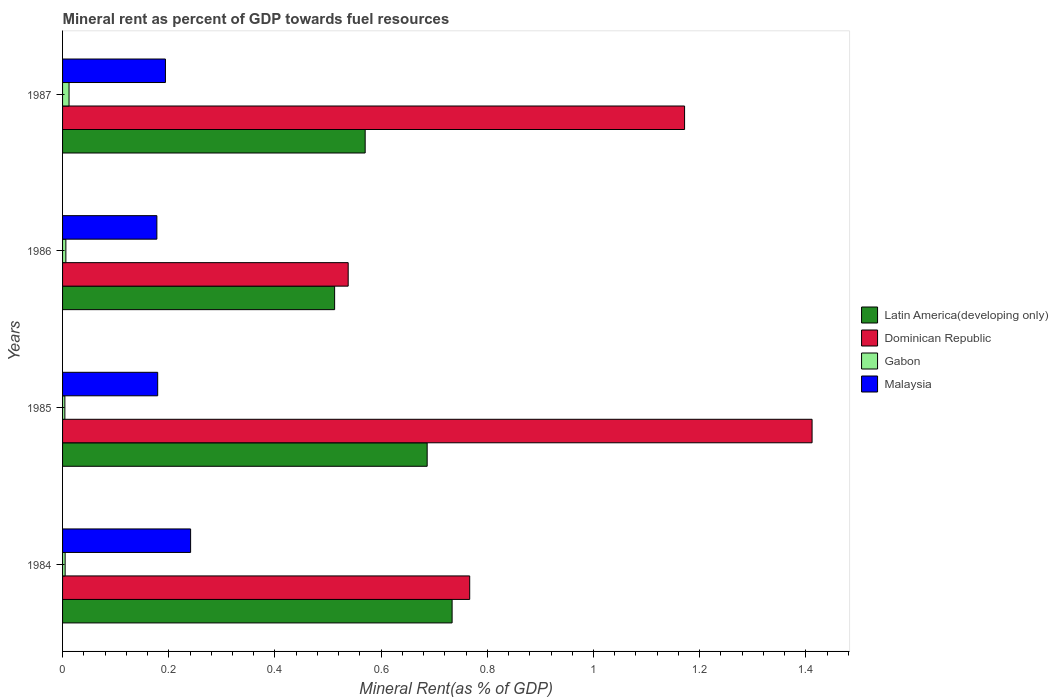How many groups of bars are there?
Give a very brief answer. 4. How many bars are there on the 1st tick from the top?
Ensure brevity in your answer.  4. How many bars are there on the 1st tick from the bottom?
Offer a terse response. 4. What is the label of the 2nd group of bars from the top?
Offer a terse response. 1986. What is the mineral rent in Latin America(developing only) in 1984?
Provide a short and direct response. 0.73. Across all years, what is the maximum mineral rent in Latin America(developing only)?
Ensure brevity in your answer.  0.73. Across all years, what is the minimum mineral rent in Dominican Republic?
Make the answer very short. 0.54. In which year was the mineral rent in Dominican Republic maximum?
Your answer should be compact. 1985. What is the total mineral rent in Gabon in the graph?
Ensure brevity in your answer.  0.03. What is the difference between the mineral rent in Dominican Republic in 1985 and that in 1987?
Give a very brief answer. 0.24. What is the difference between the mineral rent in Malaysia in 1986 and the mineral rent in Dominican Republic in 1984?
Give a very brief answer. -0.59. What is the average mineral rent in Latin America(developing only) per year?
Offer a very short reply. 0.63. In the year 1987, what is the difference between the mineral rent in Latin America(developing only) and mineral rent in Gabon?
Your answer should be very brief. 0.56. What is the ratio of the mineral rent in Dominican Republic in 1985 to that in 1986?
Give a very brief answer. 2.62. Is the mineral rent in Malaysia in 1985 less than that in 1987?
Keep it short and to the point. Yes. What is the difference between the highest and the second highest mineral rent in Dominican Republic?
Your answer should be compact. 0.24. What is the difference between the highest and the lowest mineral rent in Dominican Republic?
Offer a very short reply. 0.87. In how many years, is the mineral rent in Gabon greater than the average mineral rent in Gabon taken over all years?
Provide a short and direct response. 1. Is the sum of the mineral rent in Malaysia in 1984 and 1985 greater than the maximum mineral rent in Latin America(developing only) across all years?
Keep it short and to the point. No. Is it the case that in every year, the sum of the mineral rent in Latin America(developing only) and mineral rent in Gabon is greater than the sum of mineral rent in Dominican Republic and mineral rent in Malaysia?
Your response must be concise. Yes. What does the 2nd bar from the top in 1984 represents?
Your answer should be very brief. Gabon. What does the 1st bar from the bottom in 1984 represents?
Provide a short and direct response. Latin America(developing only). Is it the case that in every year, the sum of the mineral rent in Dominican Republic and mineral rent in Gabon is greater than the mineral rent in Malaysia?
Provide a succinct answer. Yes. How many bars are there?
Give a very brief answer. 16. Are all the bars in the graph horizontal?
Offer a very short reply. Yes. How many years are there in the graph?
Offer a terse response. 4. What is the difference between two consecutive major ticks on the X-axis?
Offer a very short reply. 0.2. Are the values on the major ticks of X-axis written in scientific E-notation?
Provide a short and direct response. No. Does the graph contain any zero values?
Keep it short and to the point. No. Where does the legend appear in the graph?
Keep it short and to the point. Center right. What is the title of the graph?
Give a very brief answer. Mineral rent as percent of GDP towards fuel resources. Does "St. Lucia" appear as one of the legend labels in the graph?
Provide a short and direct response. No. What is the label or title of the X-axis?
Give a very brief answer. Mineral Rent(as % of GDP). What is the label or title of the Y-axis?
Your answer should be compact. Years. What is the Mineral Rent(as % of GDP) in Latin America(developing only) in 1984?
Your response must be concise. 0.73. What is the Mineral Rent(as % of GDP) in Dominican Republic in 1984?
Give a very brief answer. 0.77. What is the Mineral Rent(as % of GDP) of Gabon in 1984?
Your response must be concise. 0. What is the Mineral Rent(as % of GDP) in Malaysia in 1984?
Your answer should be compact. 0.24. What is the Mineral Rent(as % of GDP) of Latin America(developing only) in 1985?
Keep it short and to the point. 0.69. What is the Mineral Rent(as % of GDP) in Dominican Republic in 1985?
Your answer should be compact. 1.41. What is the Mineral Rent(as % of GDP) of Gabon in 1985?
Your answer should be very brief. 0. What is the Mineral Rent(as % of GDP) of Malaysia in 1985?
Keep it short and to the point. 0.18. What is the Mineral Rent(as % of GDP) in Latin America(developing only) in 1986?
Ensure brevity in your answer.  0.51. What is the Mineral Rent(as % of GDP) of Dominican Republic in 1986?
Keep it short and to the point. 0.54. What is the Mineral Rent(as % of GDP) in Gabon in 1986?
Make the answer very short. 0.01. What is the Mineral Rent(as % of GDP) in Malaysia in 1986?
Offer a terse response. 0.18. What is the Mineral Rent(as % of GDP) in Latin America(developing only) in 1987?
Ensure brevity in your answer.  0.57. What is the Mineral Rent(as % of GDP) of Dominican Republic in 1987?
Your response must be concise. 1.17. What is the Mineral Rent(as % of GDP) in Gabon in 1987?
Offer a terse response. 0.01. What is the Mineral Rent(as % of GDP) in Malaysia in 1987?
Provide a short and direct response. 0.19. Across all years, what is the maximum Mineral Rent(as % of GDP) of Latin America(developing only)?
Provide a succinct answer. 0.73. Across all years, what is the maximum Mineral Rent(as % of GDP) in Dominican Republic?
Your answer should be compact. 1.41. Across all years, what is the maximum Mineral Rent(as % of GDP) in Gabon?
Provide a short and direct response. 0.01. Across all years, what is the maximum Mineral Rent(as % of GDP) of Malaysia?
Provide a succinct answer. 0.24. Across all years, what is the minimum Mineral Rent(as % of GDP) of Latin America(developing only)?
Your response must be concise. 0.51. Across all years, what is the minimum Mineral Rent(as % of GDP) in Dominican Republic?
Your response must be concise. 0.54. Across all years, what is the minimum Mineral Rent(as % of GDP) in Gabon?
Give a very brief answer. 0. Across all years, what is the minimum Mineral Rent(as % of GDP) of Malaysia?
Provide a short and direct response. 0.18. What is the total Mineral Rent(as % of GDP) in Latin America(developing only) in the graph?
Your response must be concise. 2.5. What is the total Mineral Rent(as % of GDP) in Dominican Republic in the graph?
Your answer should be very brief. 3.89. What is the total Mineral Rent(as % of GDP) in Gabon in the graph?
Offer a terse response. 0.03. What is the total Mineral Rent(as % of GDP) of Malaysia in the graph?
Give a very brief answer. 0.79. What is the difference between the Mineral Rent(as % of GDP) in Latin America(developing only) in 1984 and that in 1985?
Your answer should be very brief. 0.05. What is the difference between the Mineral Rent(as % of GDP) in Dominican Republic in 1984 and that in 1985?
Provide a succinct answer. -0.64. What is the difference between the Mineral Rent(as % of GDP) of Gabon in 1984 and that in 1985?
Give a very brief answer. 0. What is the difference between the Mineral Rent(as % of GDP) in Malaysia in 1984 and that in 1985?
Offer a terse response. 0.06. What is the difference between the Mineral Rent(as % of GDP) in Latin America(developing only) in 1984 and that in 1986?
Give a very brief answer. 0.22. What is the difference between the Mineral Rent(as % of GDP) of Dominican Republic in 1984 and that in 1986?
Make the answer very short. 0.23. What is the difference between the Mineral Rent(as % of GDP) of Gabon in 1984 and that in 1986?
Your answer should be very brief. -0. What is the difference between the Mineral Rent(as % of GDP) in Malaysia in 1984 and that in 1986?
Your answer should be compact. 0.06. What is the difference between the Mineral Rent(as % of GDP) in Latin America(developing only) in 1984 and that in 1987?
Give a very brief answer. 0.16. What is the difference between the Mineral Rent(as % of GDP) of Dominican Republic in 1984 and that in 1987?
Offer a terse response. -0.4. What is the difference between the Mineral Rent(as % of GDP) in Gabon in 1984 and that in 1987?
Your response must be concise. -0.01. What is the difference between the Mineral Rent(as % of GDP) of Malaysia in 1984 and that in 1987?
Your answer should be very brief. 0.05. What is the difference between the Mineral Rent(as % of GDP) of Latin America(developing only) in 1985 and that in 1986?
Your response must be concise. 0.17. What is the difference between the Mineral Rent(as % of GDP) of Dominican Republic in 1985 and that in 1986?
Provide a short and direct response. 0.87. What is the difference between the Mineral Rent(as % of GDP) in Gabon in 1985 and that in 1986?
Offer a very short reply. -0. What is the difference between the Mineral Rent(as % of GDP) of Malaysia in 1985 and that in 1986?
Provide a short and direct response. 0. What is the difference between the Mineral Rent(as % of GDP) of Latin America(developing only) in 1985 and that in 1987?
Offer a very short reply. 0.12. What is the difference between the Mineral Rent(as % of GDP) of Dominican Republic in 1985 and that in 1987?
Your answer should be very brief. 0.24. What is the difference between the Mineral Rent(as % of GDP) of Gabon in 1985 and that in 1987?
Your answer should be very brief. -0.01. What is the difference between the Mineral Rent(as % of GDP) in Malaysia in 1985 and that in 1987?
Your response must be concise. -0.01. What is the difference between the Mineral Rent(as % of GDP) in Latin America(developing only) in 1986 and that in 1987?
Keep it short and to the point. -0.06. What is the difference between the Mineral Rent(as % of GDP) in Dominican Republic in 1986 and that in 1987?
Provide a short and direct response. -0.63. What is the difference between the Mineral Rent(as % of GDP) in Gabon in 1986 and that in 1987?
Provide a short and direct response. -0.01. What is the difference between the Mineral Rent(as % of GDP) of Malaysia in 1986 and that in 1987?
Provide a succinct answer. -0.02. What is the difference between the Mineral Rent(as % of GDP) in Latin America(developing only) in 1984 and the Mineral Rent(as % of GDP) in Dominican Republic in 1985?
Keep it short and to the point. -0.68. What is the difference between the Mineral Rent(as % of GDP) in Latin America(developing only) in 1984 and the Mineral Rent(as % of GDP) in Gabon in 1985?
Offer a terse response. 0.73. What is the difference between the Mineral Rent(as % of GDP) of Latin America(developing only) in 1984 and the Mineral Rent(as % of GDP) of Malaysia in 1985?
Your response must be concise. 0.55. What is the difference between the Mineral Rent(as % of GDP) in Dominican Republic in 1984 and the Mineral Rent(as % of GDP) in Gabon in 1985?
Provide a succinct answer. 0.76. What is the difference between the Mineral Rent(as % of GDP) of Dominican Republic in 1984 and the Mineral Rent(as % of GDP) of Malaysia in 1985?
Provide a short and direct response. 0.59. What is the difference between the Mineral Rent(as % of GDP) in Gabon in 1984 and the Mineral Rent(as % of GDP) in Malaysia in 1985?
Offer a terse response. -0.17. What is the difference between the Mineral Rent(as % of GDP) in Latin America(developing only) in 1984 and the Mineral Rent(as % of GDP) in Dominican Republic in 1986?
Offer a terse response. 0.2. What is the difference between the Mineral Rent(as % of GDP) of Latin America(developing only) in 1984 and the Mineral Rent(as % of GDP) of Gabon in 1986?
Your answer should be very brief. 0.73. What is the difference between the Mineral Rent(as % of GDP) in Latin America(developing only) in 1984 and the Mineral Rent(as % of GDP) in Malaysia in 1986?
Your answer should be very brief. 0.56. What is the difference between the Mineral Rent(as % of GDP) of Dominican Republic in 1984 and the Mineral Rent(as % of GDP) of Gabon in 1986?
Make the answer very short. 0.76. What is the difference between the Mineral Rent(as % of GDP) of Dominican Republic in 1984 and the Mineral Rent(as % of GDP) of Malaysia in 1986?
Provide a succinct answer. 0.59. What is the difference between the Mineral Rent(as % of GDP) of Gabon in 1984 and the Mineral Rent(as % of GDP) of Malaysia in 1986?
Your response must be concise. -0.17. What is the difference between the Mineral Rent(as % of GDP) of Latin America(developing only) in 1984 and the Mineral Rent(as % of GDP) of Dominican Republic in 1987?
Your response must be concise. -0.44. What is the difference between the Mineral Rent(as % of GDP) in Latin America(developing only) in 1984 and the Mineral Rent(as % of GDP) in Gabon in 1987?
Ensure brevity in your answer.  0.72. What is the difference between the Mineral Rent(as % of GDP) of Latin America(developing only) in 1984 and the Mineral Rent(as % of GDP) of Malaysia in 1987?
Offer a terse response. 0.54. What is the difference between the Mineral Rent(as % of GDP) of Dominican Republic in 1984 and the Mineral Rent(as % of GDP) of Gabon in 1987?
Your response must be concise. 0.75. What is the difference between the Mineral Rent(as % of GDP) in Dominican Republic in 1984 and the Mineral Rent(as % of GDP) in Malaysia in 1987?
Give a very brief answer. 0.57. What is the difference between the Mineral Rent(as % of GDP) of Gabon in 1984 and the Mineral Rent(as % of GDP) of Malaysia in 1987?
Make the answer very short. -0.19. What is the difference between the Mineral Rent(as % of GDP) in Latin America(developing only) in 1985 and the Mineral Rent(as % of GDP) in Dominican Republic in 1986?
Keep it short and to the point. 0.15. What is the difference between the Mineral Rent(as % of GDP) in Latin America(developing only) in 1985 and the Mineral Rent(as % of GDP) in Gabon in 1986?
Your response must be concise. 0.68. What is the difference between the Mineral Rent(as % of GDP) in Latin America(developing only) in 1985 and the Mineral Rent(as % of GDP) in Malaysia in 1986?
Provide a short and direct response. 0.51. What is the difference between the Mineral Rent(as % of GDP) of Dominican Republic in 1985 and the Mineral Rent(as % of GDP) of Gabon in 1986?
Give a very brief answer. 1.41. What is the difference between the Mineral Rent(as % of GDP) of Dominican Republic in 1985 and the Mineral Rent(as % of GDP) of Malaysia in 1986?
Give a very brief answer. 1.23. What is the difference between the Mineral Rent(as % of GDP) of Gabon in 1985 and the Mineral Rent(as % of GDP) of Malaysia in 1986?
Offer a terse response. -0.17. What is the difference between the Mineral Rent(as % of GDP) of Latin America(developing only) in 1985 and the Mineral Rent(as % of GDP) of Dominican Republic in 1987?
Make the answer very short. -0.48. What is the difference between the Mineral Rent(as % of GDP) of Latin America(developing only) in 1985 and the Mineral Rent(as % of GDP) of Gabon in 1987?
Your answer should be very brief. 0.67. What is the difference between the Mineral Rent(as % of GDP) in Latin America(developing only) in 1985 and the Mineral Rent(as % of GDP) in Malaysia in 1987?
Give a very brief answer. 0.49. What is the difference between the Mineral Rent(as % of GDP) in Dominican Republic in 1985 and the Mineral Rent(as % of GDP) in Gabon in 1987?
Provide a succinct answer. 1.4. What is the difference between the Mineral Rent(as % of GDP) in Dominican Republic in 1985 and the Mineral Rent(as % of GDP) in Malaysia in 1987?
Your response must be concise. 1.22. What is the difference between the Mineral Rent(as % of GDP) of Gabon in 1985 and the Mineral Rent(as % of GDP) of Malaysia in 1987?
Ensure brevity in your answer.  -0.19. What is the difference between the Mineral Rent(as % of GDP) in Latin America(developing only) in 1986 and the Mineral Rent(as % of GDP) in Dominican Republic in 1987?
Ensure brevity in your answer.  -0.66. What is the difference between the Mineral Rent(as % of GDP) in Latin America(developing only) in 1986 and the Mineral Rent(as % of GDP) in Gabon in 1987?
Provide a succinct answer. 0.5. What is the difference between the Mineral Rent(as % of GDP) of Latin America(developing only) in 1986 and the Mineral Rent(as % of GDP) of Malaysia in 1987?
Give a very brief answer. 0.32. What is the difference between the Mineral Rent(as % of GDP) in Dominican Republic in 1986 and the Mineral Rent(as % of GDP) in Gabon in 1987?
Ensure brevity in your answer.  0.53. What is the difference between the Mineral Rent(as % of GDP) in Dominican Republic in 1986 and the Mineral Rent(as % of GDP) in Malaysia in 1987?
Your answer should be compact. 0.34. What is the difference between the Mineral Rent(as % of GDP) of Gabon in 1986 and the Mineral Rent(as % of GDP) of Malaysia in 1987?
Your response must be concise. -0.19. What is the average Mineral Rent(as % of GDP) in Latin America(developing only) per year?
Offer a very short reply. 0.63. What is the average Mineral Rent(as % of GDP) of Dominican Republic per year?
Offer a very short reply. 0.97. What is the average Mineral Rent(as % of GDP) of Gabon per year?
Offer a terse response. 0.01. What is the average Mineral Rent(as % of GDP) in Malaysia per year?
Your answer should be very brief. 0.2. In the year 1984, what is the difference between the Mineral Rent(as % of GDP) in Latin America(developing only) and Mineral Rent(as % of GDP) in Dominican Republic?
Offer a terse response. -0.03. In the year 1984, what is the difference between the Mineral Rent(as % of GDP) of Latin America(developing only) and Mineral Rent(as % of GDP) of Gabon?
Your answer should be very brief. 0.73. In the year 1984, what is the difference between the Mineral Rent(as % of GDP) of Latin America(developing only) and Mineral Rent(as % of GDP) of Malaysia?
Offer a very short reply. 0.49. In the year 1984, what is the difference between the Mineral Rent(as % of GDP) of Dominican Republic and Mineral Rent(as % of GDP) of Gabon?
Your answer should be very brief. 0.76. In the year 1984, what is the difference between the Mineral Rent(as % of GDP) in Dominican Republic and Mineral Rent(as % of GDP) in Malaysia?
Your answer should be very brief. 0.53. In the year 1984, what is the difference between the Mineral Rent(as % of GDP) of Gabon and Mineral Rent(as % of GDP) of Malaysia?
Give a very brief answer. -0.24. In the year 1985, what is the difference between the Mineral Rent(as % of GDP) of Latin America(developing only) and Mineral Rent(as % of GDP) of Dominican Republic?
Offer a very short reply. -0.72. In the year 1985, what is the difference between the Mineral Rent(as % of GDP) in Latin America(developing only) and Mineral Rent(as % of GDP) in Gabon?
Your answer should be very brief. 0.68. In the year 1985, what is the difference between the Mineral Rent(as % of GDP) in Latin America(developing only) and Mineral Rent(as % of GDP) in Malaysia?
Make the answer very short. 0.51. In the year 1985, what is the difference between the Mineral Rent(as % of GDP) of Dominican Republic and Mineral Rent(as % of GDP) of Gabon?
Your response must be concise. 1.41. In the year 1985, what is the difference between the Mineral Rent(as % of GDP) in Dominican Republic and Mineral Rent(as % of GDP) in Malaysia?
Offer a terse response. 1.23. In the year 1985, what is the difference between the Mineral Rent(as % of GDP) in Gabon and Mineral Rent(as % of GDP) in Malaysia?
Provide a short and direct response. -0.17. In the year 1986, what is the difference between the Mineral Rent(as % of GDP) in Latin America(developing only) and Mineral Rent(as % of GDP) in Dominican Republic?
Ensure brevity in your answer.  -0.03. In the year 1986, what is the difference between the Mineral Rent(as % of GDP) in Latin America(developing only) and Mineral Rent(as % of GDP) in Gabon?
Make the answer very short. 0.51. In the year 1986, what is the difference between the Mineral Rent(as % of GDP) of Latin America(developing only) and Mineral Rent(as % of GDP) of Malaysia?
Offer a terse response. 0.33. In the year 1986, what is the difference between the Mineral Rent(as % of GDP) of Dominican Republic and Mineral Rent(as % of GDP) of Gabon?
Your answer should be compact. 0.53. In the year 1986, what is the difference between the Mineral Rent(as % of GDP) in Dominican Republic and Mineral Rent(as % of GDP) in Malaysia?
Keep it short and to the point. 0.36. In the year 1986, what is the difference between the Mineral Rent(as % of GDP) of Gabon and Mineral Rent(as % of GDP) of Malaysia?
Offer a terse response. -0.17. In the year 1987, what is the difference between the Mineral Rent(as % of GDP) of Latin America(developing only) and Mineral Rent(as % of GDP) of Dominican Republic?
Provide a succinct answer. -0.6. In the year 1987, what is the difference between the Mineral Rent(as % of GDP) of Latin America(developing only) and Mineral Rent(as % of GDP) of Gabon?
Offer a terse response. 0.56. In the year 1987, what is the difference between the Mineral Rent(as % of GDP) in Latin America(developing only) and Mineral Rent(as % of GDP) in Malaysia?
Offer a very short reply. 0.38. In the year 1987, what is the difference between the Mineral Rent(as % of GDP) in Dominican Republic and Mineral Rent(as % of GDP) in Gabon?
Offer a very short reply. 1.16. In the year 1987, what is the difference between the Mineral Rent(as % of GDP) of Dominican Republic and Mineral Rent(as % of GDP) of Malaysia?
Your response must be concise. 0.98. In the year 1987, what is the difference between the Mineral Rent(as % of GDP) in Gabon and Mineral Rent(as % of GDP) in Malaysia?
Offer a very short reply. -0.18. What is the ratio of the Mineral Rent(as % of GDP) in Latin America(developing only) in 1984 to that in 1985?
Your answer should be compact. 1.07. What is the ratio of the Mineral Rent(as % of GDP) in Dominican Republic in 1984 to that in 1985?
Keep it short and to the point. 0.54. What is the ratio of the Mineral Rent(as % of GDP) of Gabon in 1984 to that in 1985?
Your answer should be very brief. 1.11. What is the ratio of the Mineral Rent(as % of GDP) of Malaysia in 1984 to that in 1985?
Keep it short and to the point. 1.35. What is the ratio of the Mineral Rent(as % of GDP) in Latin America(developing only) in 1984 to that in 1986?
Your answer should be very brief. 1.43. What is the ratio of the Mineral Rent(as % of GDP) in Dominican Republic in 1984 to that in 1986?
Your response must be concise. 1.43. What is the ratio of the Mineral Rent(as % of GDP) in Gabon in 1984 to that in 1986?
Keep it short and to the point. 0.78. What is the ratio of the Mineral Rent(as % of GDP) in Malaysia in 1984 to that in 1986?
Give a very brief answer. 1.36. What is the ratio of the Mineral Rent(as % of GDP) in Latin America(developing only) in 1984 to that in 1987?
Keep it short and to the point. 1.29. What is the ratio of the Mineral Rent(as % of GDP) in Dominican Republic in 1984 to that in 1987?
Offer a very short reply. 0.65. What is the ratio of the Mineral Rent(as % of GDP) of Gabon in 1984 to that in 1987?
Provide a succinct answer. 0.4. What is the ratio of the Mineral Rent(as % of GDP) of Malaysia in 1984 to that in 1987?
Your response must be concise. 1.24. What is the ratio of the Mineral Rent(as % of GDP) of Latin America(developing only) in 1985 to that in 1986?
Your response must be concise. 1.34. What is the ratio of the Mineral Rent(as % of GDP) in Dominican Republic in 1985 to that in 1986?
Your answer should be compact. 2.62. What is the ratio of the Mineral Rent(as % of GDP) in Gabon in 1985 to that in 1986?
Offer a terse response. 0.7. What is the ratio of the Mineral Rent(as % of GDP) in Malaysia in 1985 to that in 1986?
Offer a very short reply. 1.01. What is the ratio of the Mineral Rent(as % of GDP) of Latin America(developing only) in 1985 to that in 1987?
Ensure brevity in your answer.  1.2. What is the ratio of the Mineral Rent(as % of GDP) of Dominican Republic in 1985 to that in 1987?
Your response must be concise. 1.21. What is the ratio of the Mineral Rent(as % of GDP) in Gabon in 1985 to that in 1987?
Provide a short and direct response. 0.36. What is the ratio of the Mineral Rent(as % of GDP) of Malaysia in 1985 to that in 1987?
Provide a succinct answer. 0.92. What is the ratio of the Mineral Rent(as % of GDP) in Latin America(developing only) in 1986 to that in 1987?
Your answer should be very brief. 0.9. What is the ratio of the Mineral Rent(as % of GDP) of Dominican Republic in 1986 to that in 1987?
Make the answer very short. 0.46. What is the ratio of the Mineral Rent(as % of GDP) in Gabon in 1986 to that in 1987?
Ensure brevity in your answer.  0.51. What is the ratio of the Mineral Rent(as % of GDP) of Malaysia in 1986 to that in 1987?
Give a very brief answer. 0.92. What is the difference between the highest and the second highest Mineral Rent(as % of GDP) of Latin America(developing only)?
Give a very brief answer. 0.05. What is the difference between the highest and the second highest Mineral Rent(as % of GDP) of Dominican Republic?
Offer a terse response. 0.24. What is the difference between the highest and the second highest Mineral Rent(as % of GDP) of Gabon?
Give a very brief answer. 0.01. What is the difference between the highest and the second highest Mineral Rent(as % of GDP) in Malaysia?
Provide a short and direct response. 0.05. What is the difference between the highest and the lowest Mineral Rent(as % of GDP) of Latin America(developing only)?
Offer a very short reply. 0.22. What is the difference between the highest and the lowest Mineral Rent(as % of GDP) in Dominican Republic?
Provide a short and direct response. 0.87. What is the difference between the highest and the lowest Mineral Rent(as % of GDP) in Gabon?
Provide a short and direct response. 0.01. What is the difference between the highest and the lowest Mineral Rent(as % of GDP) of Malaysia?
Ensure brevity in your answer.  0.06. 